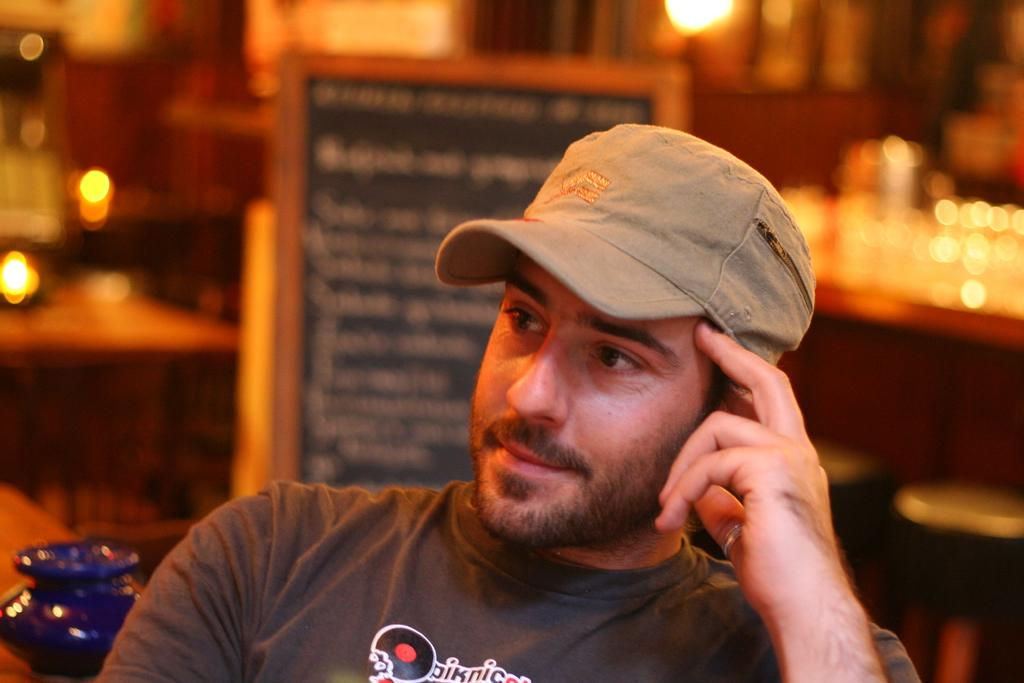What is the main subject of the image? There is a person in the image. What object is visible behind the person? There is a display board in the image. Can you describe the position of the display board in relation to the person? The display board is behind the person. What type of stove is being used to make jam in the image? There is no stove or jam present in the image. 